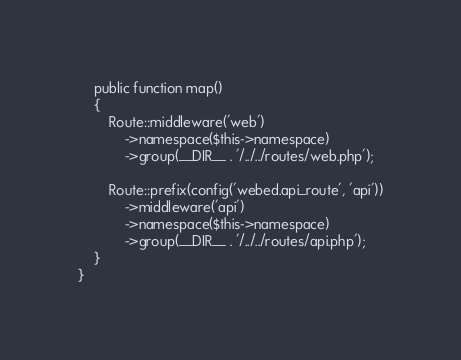<code> <loc_0><loc_0><loc_500><loc_500><_PHP_>    public function map()
    {
        Route::middleware('web')
            ->namespace($this->namespace)
            ->group(__DIR__ . '/../../routes/web.php');

        Route::prefix(config('webed.api_route', 'api'))
            ->middleware('api')
            ->namespace($this->namespace)
            ->group(__DIR__ . '/../../routes/api.php');
    }
}
</code> 